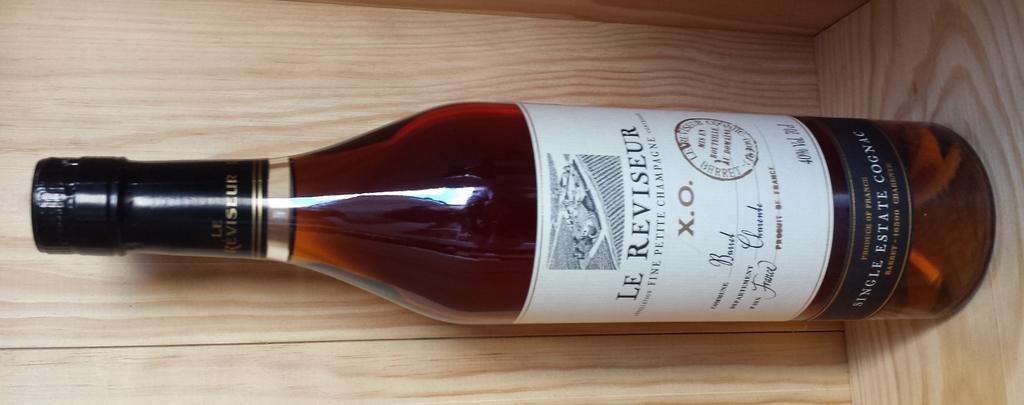How would you summarize this image in a sentence or two? In this image we can see a alcohol bottle on the wooden surface. 